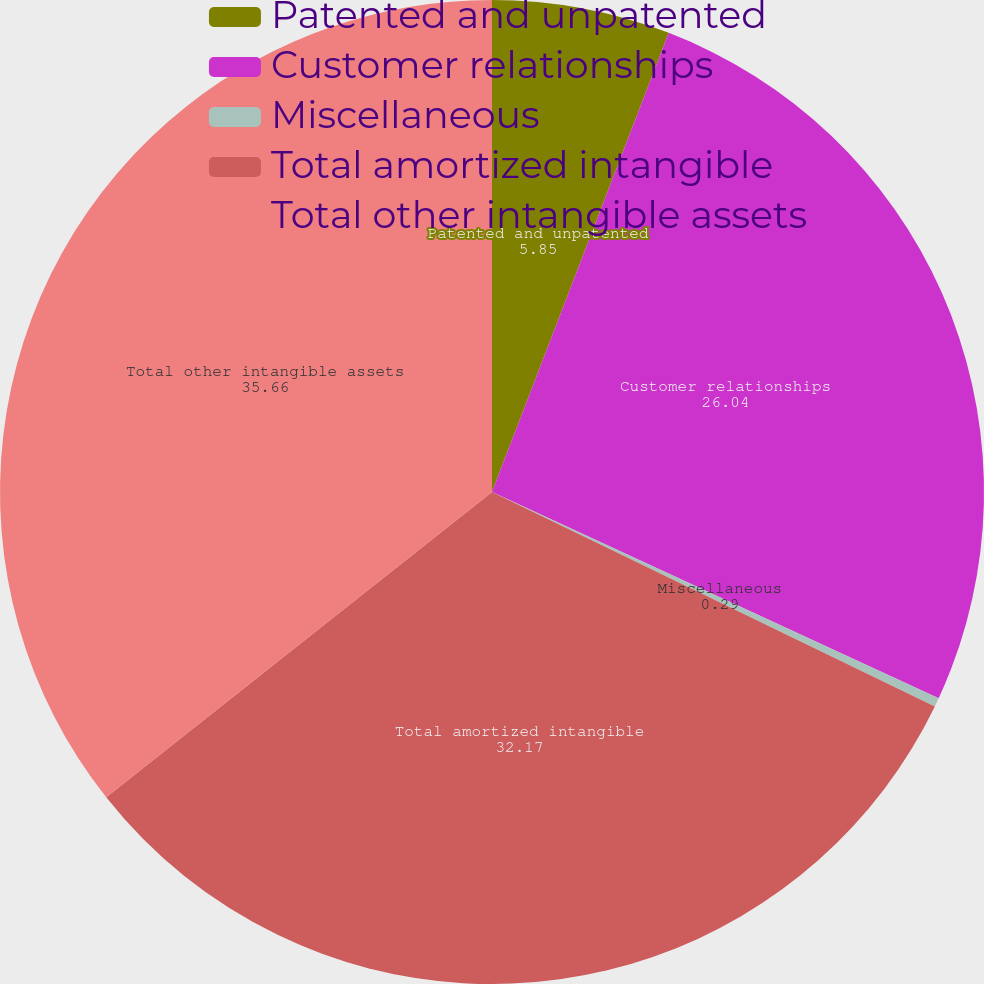Convert chart to OTSL. <chart><loc_0><loc_0><loc_500><loc_500><pie_chart><fcel>Patented and unpatented<fcel>Customer relationships<fcel>Miscellaneous<fcel>Total amortized intangible<fcel>Total other intangible assets<nl><fcel>5.85%<fcel>26.04%<fcel>0.29%<fcel>32.17%<fcel>35.66%<nl></chart> 